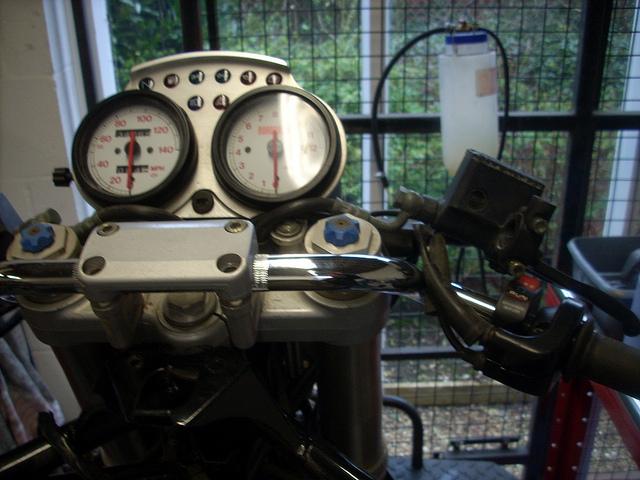What vehicle is this?
Answer briefly. Motorcycle. Is that a clock on the handlebar?
Answer briefly. No. What are the meters for?
Be succinct. Speed and rpm. Where is this happening?
Keep it brief. Garage. What number does the speedometer go up to?
Write a very short answer. 140. 